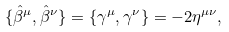Convert formula to latex. <formula><loc_0><loc_0><loc_500><loc_500>\{ { \hat { \beta } } ^ { \mu } , { \hat { \beta } } ^ { \nu } \} = \{ \gamma ^ { \mu } , \gamma ^ { \nu } \} = - 2 \eta ^ { \mu \nu } ,</formula> 